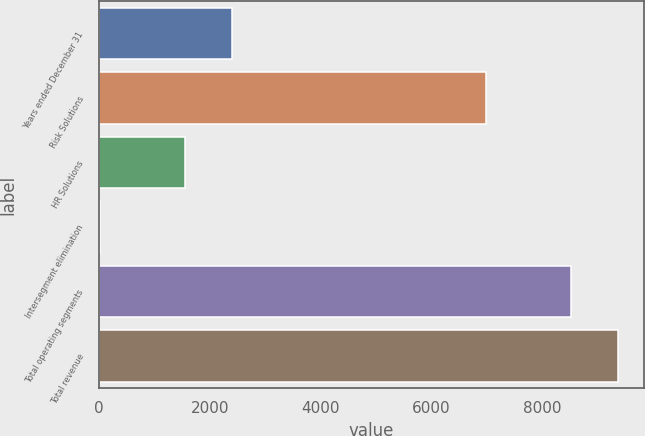Convert chart to OTSL. <chart><loc_0><loc_0><loc_500><loc_500><bar_chart><fcel>Years ended December 31<fcel>Risk Solutions<fcel>HR Solutions<fcel>Intersegment elimination<fcel>Total operating segments<fcel>Total revenue<nl><fcel>2394<fcel>6989<fcel>1545<fcel>22<fcel>8512<fcel>9361<nl></chart> 